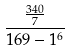Convert formula to latex. <formula><loc_0><loc_0><loc_500><loc_500>\frac { \frac { 3 4 0 } { 7 } } { 1 6 9 - 1 ^ { 6 } }</formula> 